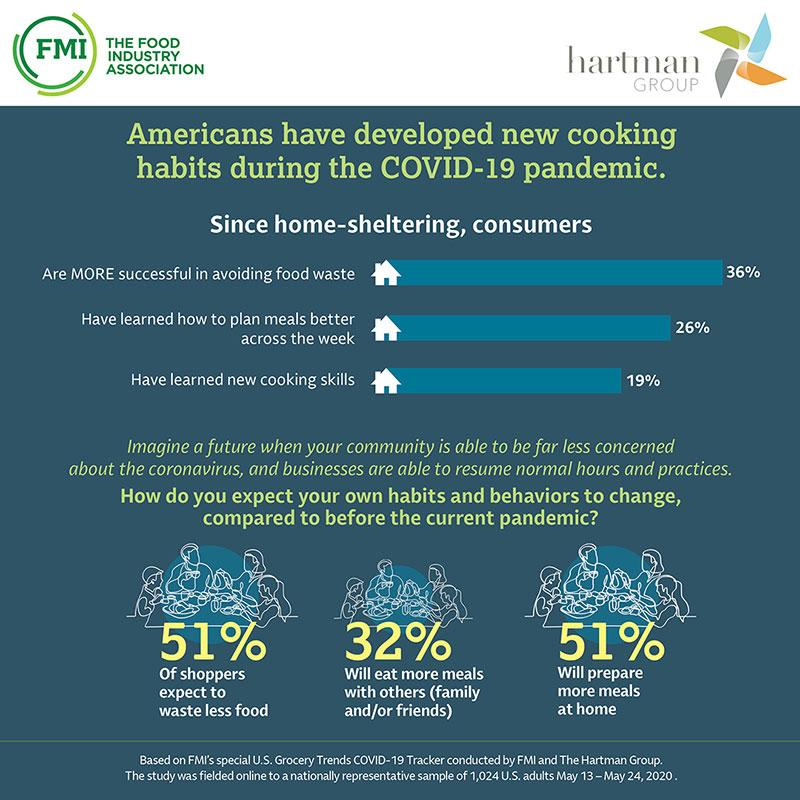Draw attention to some important aspects in this diagram. According to the survey, 32% of respondents indicated that they would prefer to eat more meals with others, specifically with family and/or friends. According to a recent survey, it is expected that 51% of people will prepare more meals at home than they did before the pandemic. According to a survey, 19% of consumers have developed new cooking skills, making it a widely developed skill among consumers. 